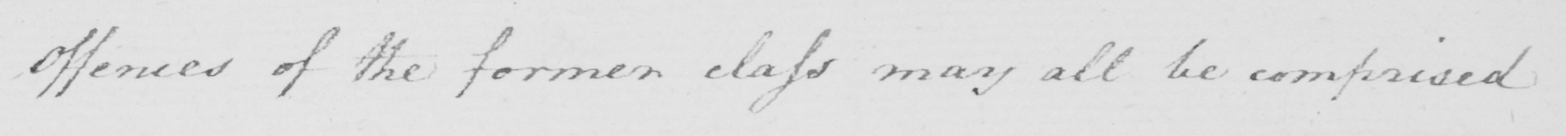Transcribe the text shown in this historical manuscript line. Offences of the former class may all be comprised 